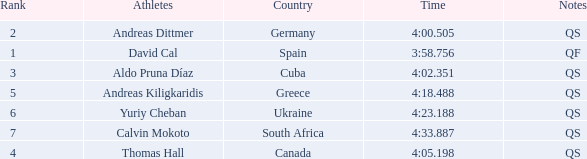What are the notes for the athlete from South Africa? QS. 